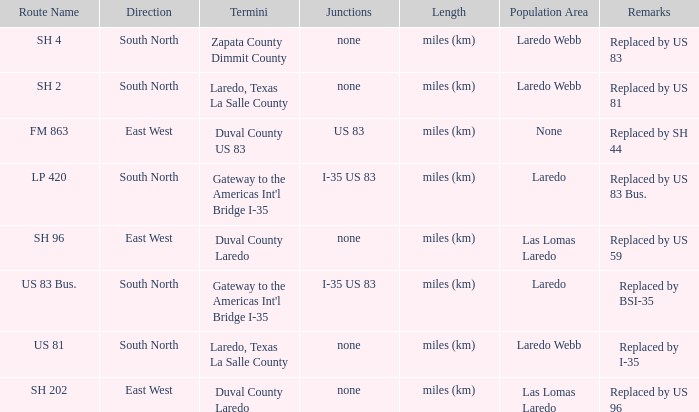How many termini are there that have "east west" listed in their direction section, "none" listed in their junction section, and have a route name of "sh 202"? 1.0. 